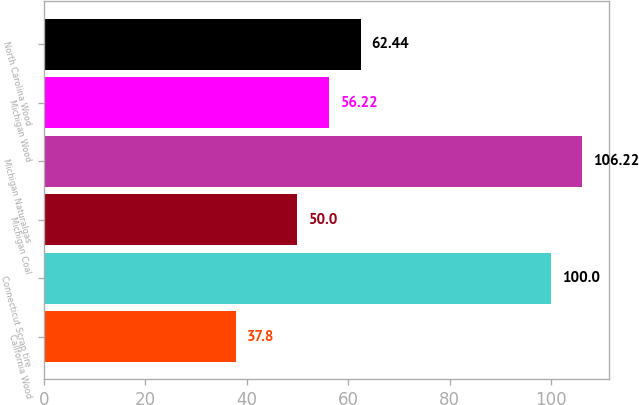Convert chart. <chart><loc_0><loc_0><loc_500><loc_500><bar_chart><fcel>California Wood<fcel>Connecticut Scrap tire<fcel>Michigan Coal<fcel>Michigan Naturalgas<fcel>Michigan Wood<fcel>North Carolina Wood<nl><fcel>37.8<fcel>100<fcel>50<fcel>106.22<fcel>56.22<fcel>62.44<nl></chart> 